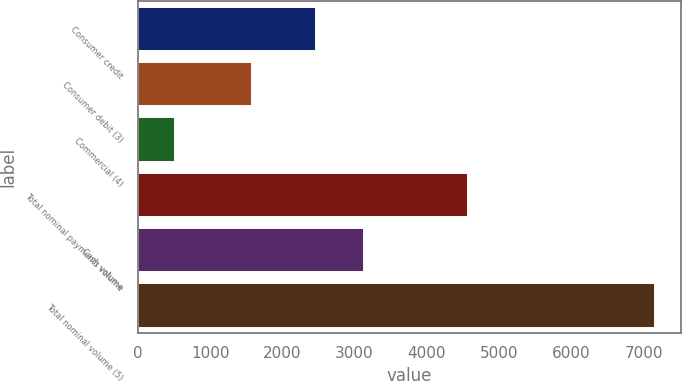Convert chart to OTSL. <chart><loc_0><loc_0><loc_500><loc_500><bar_chart><fcel>Consumer credit<fcel>Consumer debit (3)<fcel>Commercial (4)<fcel>Total nominal payments volume<fcel>Cash volume<fcel>Total nominal volume (5)<nl><fcel>2471<fcel>1581<fcel>515<fcel>4567<fcel>3135.2<fcel>7157<nl></chart> 